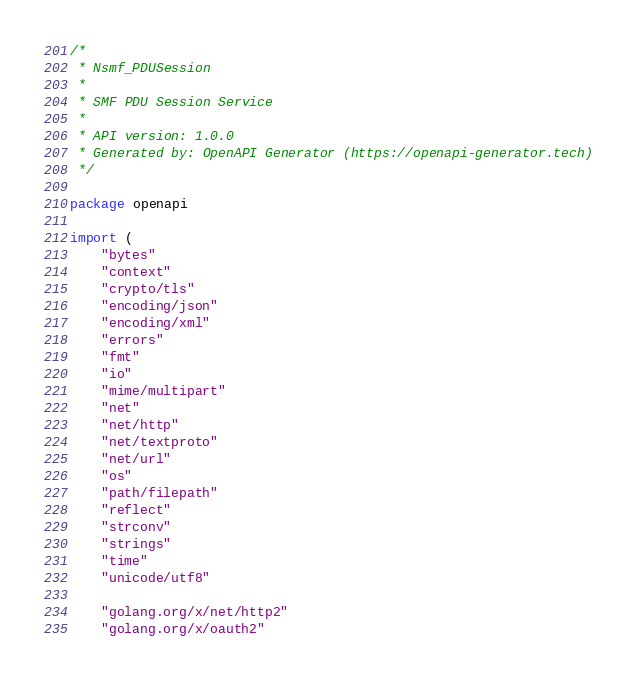<code> <loc_0><loc_0><loc_500><loc_500><_Go_>/*
 * Nsmf_PDUSession
 *
 * SMF PDU Session Service
 *
 * API version: 1.0.0
 * Generated by: OpenAPI Generator (https://openapi-generator.tech)
 */

package openapi

import (
	"bytes"
	"context"
	"crypto/tls"
	"encoding/json"
	"encoding/xml"
	"errors"
	"fmt"
	"io"
	"mime/multipart"
	"net"
	"net/http"
	"net/textproto"
	"net/url"
	"os"
	"path/filepath"
	"reflect"
	"strconv"
	"strings"
	"time"
	"unicode/utf8"

	"golang.org/x/net/http2"
	"golang.org/x/oauth2"
</code> 